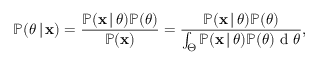<formula> <loc_0><loc_0><loc_500><loc_500>\mathbb { P } ( \theta \, | \, x ) = \frac { \mathbb { P } ( x \, | \, \theta ) \mathbb { P } ( \theta ) } { \mathbb { P } ( x ) } = \frac { \mathbb { P } ( x \, | \, \theta ) \mathbb { P } ( \theta ) } { \int _ { \Theta } \mathbb { P } ( x \, | \, \theta ) \mathbb { P } ( \theta ) d \theta } ,</formula> 